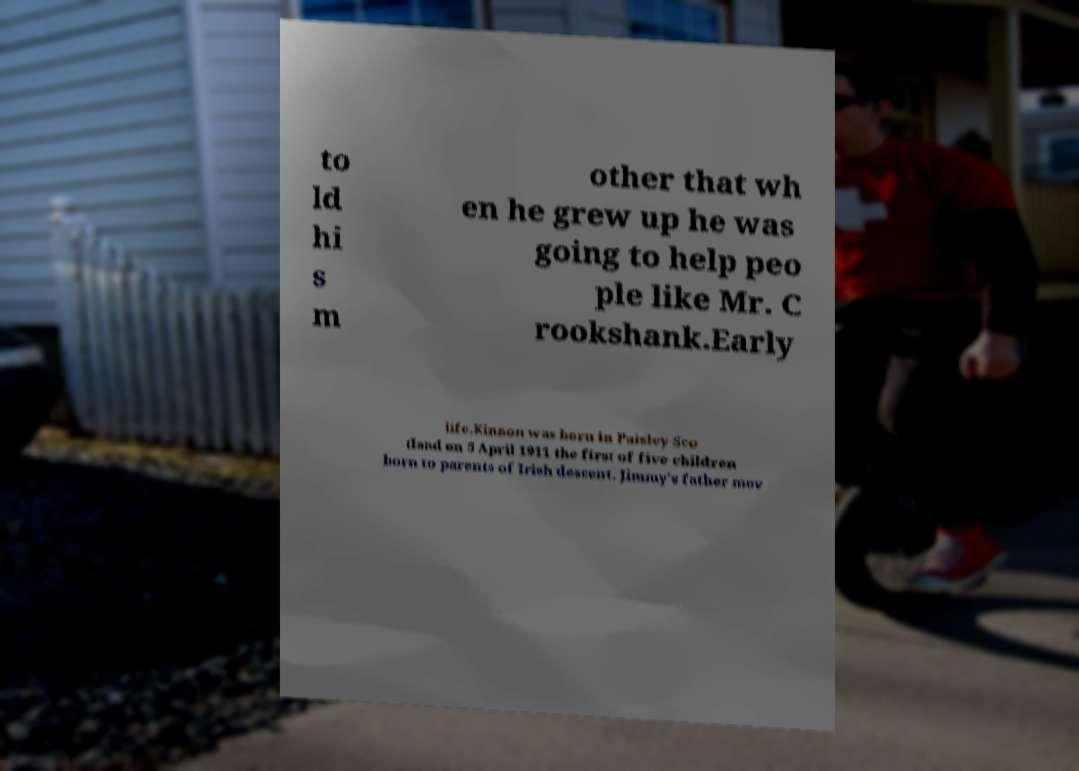Could you assist in decoding the text presented in this image and type it out clearly? to ld hi s m other that wh en he grew up he was going to help peo ple like Mr. C rookshank.Early life.Kinnon was born in Paisley Sco tland on 5 April 1911 the first of five children born to parents of Irish descent. Jimmy's father mov 